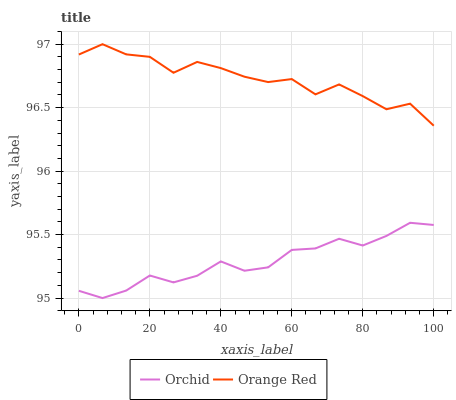Does Orchid have the minimum area under the curve?
Answer yes or no. Yes. Does Orange Red have the maximum area under the curve?
Answer yes or no. Yes. Does Orchid have the maximum area under the curve?
Answer yes or no. No. Is Orchid the smoothest?
Answer yes or no. Yes. Is Orange Red the roughest?
Answer yes or no. Yes. Is Orchid the roughest?
Answer yes or no. No. Does Orchid have the lowest value?
Answer yes or no. Yes. Does Orange Red have the highest value?
Answer yes or no. Yes. Does Orchid have the highest value?
Answer yes or no. No. Is Orchid less than Orange Red?
Answer yes or no. Yes. Is Orange Red greater than Orchid?
Answer yes or no. Yes. Does Orchid intersect Orange Red?
Answer yes or no. No. 